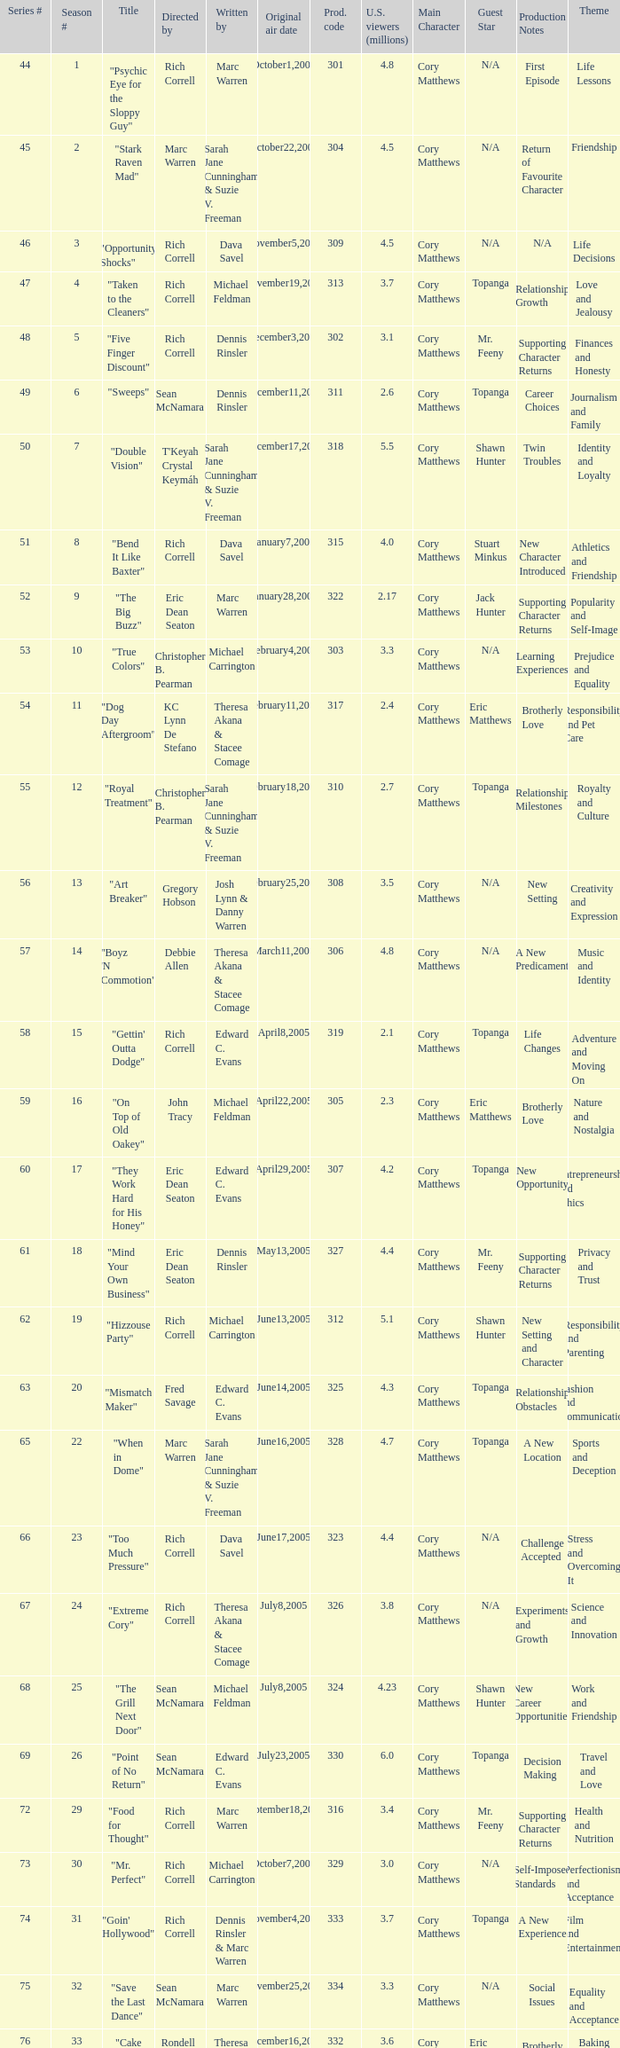What number episode of the season was titled "Vision Impossible"? 34.0. 